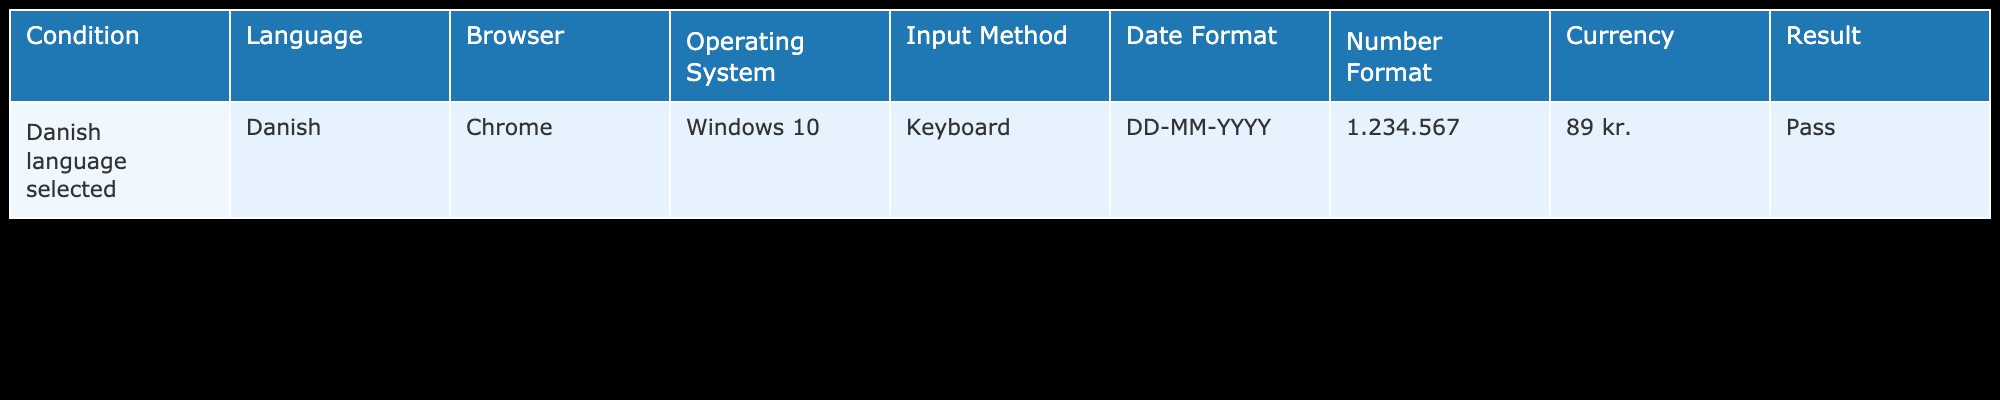What language was selected in the localization testing scenario? The table indicates that the Danish language was selected for the testing scenario.
Answer: Danish Which browser was used during the localization testing? The testing was conducted using the Chrome browser as stated in the table.
Answer: Chrome What is the currency format used for the Danish localization? The currency format specified in the table for Danish localization is 89 kr.
Answer: 89 kr Is the date format in the correct style for the Danish language? The table presents the date format as DD-MM-YYYY, which is consistent with the standard used in Denmark.
Answer: Yes What is the number format used in the Danish localization testing scenario? The number specified in the table is formatted as 1.234.567, which is appropriate for the Danish localization.
Answer: 1.234.567 How many formats (date, number, currency) are compliant with the Danish language? The table shows that all three formats (date format DD-MM-YYYY, number format 1.234.567, and currency format 89 kr.) are compliant with Danish standards, indicating compliance across the board.
Answer: Three formats Based on the table, is it true that the localization testing passed the criteria set? The result in the table indicates "Pass," showing that the localization testing met the outlined criteria.
Answer: Yes If the same tests were executed in English, would the date format remain the same? The date format used in Danish localization (DD-MM-YYYY) differs from the common format in English-speaking countries (MM-DD-YYYY), indicating that the date format would not remain the same if tests were run in English.
Answer: No What are the distinct elements included in the testing scenario (Language, Browser, Operating System, Input Method)? Distinct elements from the table include Language: Danish, Browser: Chrome, Operating System: Windows 10, and Input Method: Keyboard, all contributing to the overall testing scenario setup.
Answer: Four elements 